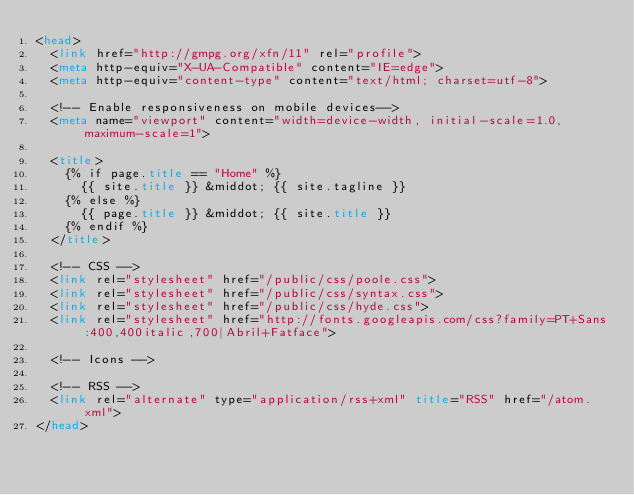<code> <loc_0><loc_0><loc_500><loc_500><_HTML_><head>
  <link href="http://gmpg.org/xfn/11" rel="profile">
  <meta http-equiv="X-UA-Compatible" content="IE=edge">
  <meta http-equiv="content-type" content="text/html; charset=utf-8">

  <!-- Enable responsiveness on mobile devices-->
  <meta name="viewport" content="width=device-width, initial-scale=1.0, maximum-scale=1">

  <title>
    {% if page.title == "Home" %}
      {{ site.title }} &middot; {{ site.tagline }}
    {% else %}
      {{ page.title }} &middot; {{ site.title }}
    {% endif %}
  </title>

  <!-- CSS -->
  <link rel="stylesheet" href="/public/css/poole.css">
  <link rel="stylesheet" href="/public/css/syntax.css">
  <link rel="stylesheet" href="/public/css/hyde.css">
  <link rel="stylesheet" href="http://fonts.googleapis.com/css?family=PT+Sans:400,400italic,700|Abril+Fatface">

  <!-- Icons -->

  <!-- RSS -->
  <link rel="alternate" type="application/rss+xml" title="RSS" href="/atom.xml">
</head>
</code> 